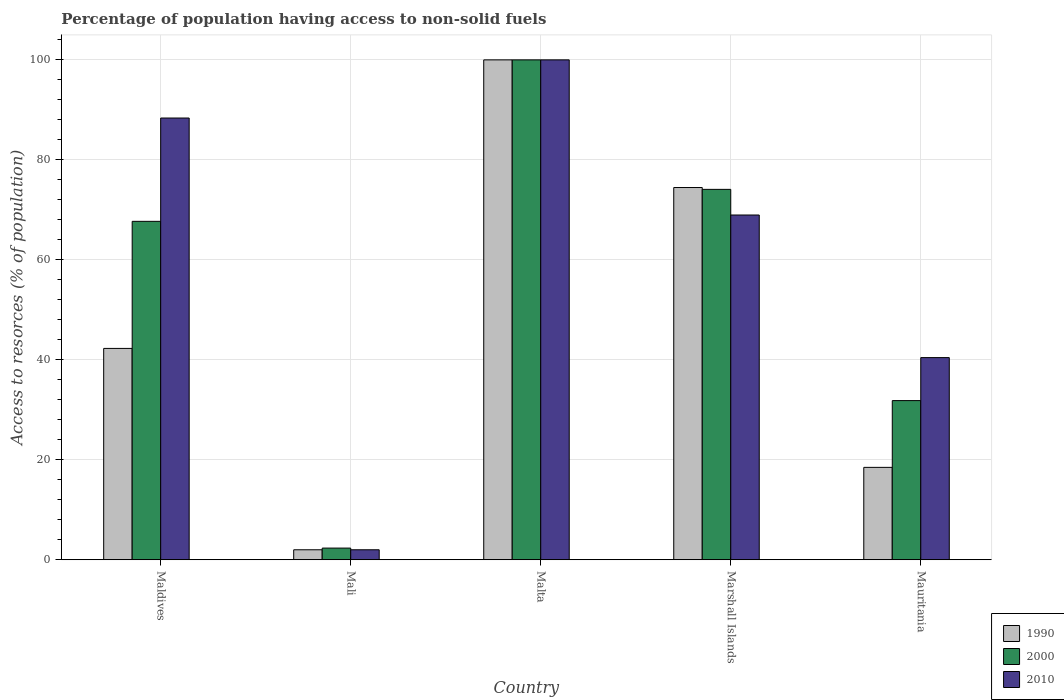How many different coloured bars are there?
Provide a short and direct response. 3. How many bars are there on the 1st tick from the right?
Your response must be concise. 3. What is the label of the 5th group of bars from the left?
Offer a very short reply. Mauritania. What is the percentage of population having access to non-solid fuels in 1990 in Marshall Islands?
Offer a terse response. 74.47. Across all countries, what is the maximum percentage of population having access to non-solid fuels in 1990?
Offer a terse response. 100. Across all countries, what is the minimum percentage of population having access to non-solid fuels in 2010?
Keep it short and to the point. 2. In which country was the percentage of population having access to non-solid fuels in 1990 maximum?
Offer a terse response. Malta. In which country was the percentage of population having access to non-solid fuels in 2010 minimum?
Your response must be concise. Mali. What is the total percentage of population having access to non-solid fuels in 2010 in the graph?
Ensure brevity in your answer.  299.78. What is the difference between the percentage of population having access to non-solid fuels in 2000 in Malta and that in Marshall Islands?
Your answer should be very brief. 25.91. What is the difference between the percentage of population having access to non-solid fuels in 1990 in Malta and the percentage of population having access to non-solid fuels in 2010 in Maldives?
Offer a terse response. 11.63. What is the average percentage of population having access to non-solid fuels in 2010 per country?
Your response must be concise. 59.96. What is the difference between the percentage of population having access to non-solid fuels of/in 2010 and percentage of population having access to non-solid fuels of/in 2000 in Mauritania?
Keep it short and to the point. 8.6. What is the ratio of the percentage of population having access to non-solid fuels in 2010 in Marshall Islands to that in Mauritania?
Keep it short and to the point. 1.71. Is the percentage of population having access to non-solid fuels in 2010 in Mali less than that in Mauritania?
Your answer should be very brief. Yes. What is the difference between the highest and the second highest percentage of population having access to non-solid fuels in 2010?
Your answer should be compact. -11.63. What is the difference between the highest and the lowest percentage of population having access to non-solid fuels in 2000?
Provide a short and direct response. 97.66. In how many countries, is the percentage of population having access to non-solid fuels in 1990 greater than the average percentage of population having access to non-solid fuels in 1990 taken over all countries?
Provide a succinct answer. 2. What does the 2nd bar from the left in Malta represents?
Provide a succinct answer. 2000. What does the 2nd bar from the right in Maldives represents?
Your response must be concise. 2000. Is it the case that in every country, the sum of the percentage of population having access to non-solid fuels in 2010 and percentage of population having access to non-solid fuels in 1990 is greater than the percentage of population having access to non-solid fuels in 2000?
Provide a succinct answer. Yes. How many bars are there?
Provide a short and direct response. 15. How many countries are there in the graph?
Offer a very short reply. 5. What is the difference between two consecutive major ticks on the Y-axis?
Keep it short and to the point. 20. Are the values on the major ticks of Y-axis written in scientific E-notation?
Offer a terse response. No. Does the graph contain grids?
Your answer should be very brief. Yes. Where does the legend appear in the graph?
Ensure brevity in your answer.  Bottom right. How are the legend labels stacked?
Your answer should be compact. Vertical. What is the title of the graph?
Give a very brief answer. Percentage of population having access to non-solid fuels. Does "1988" appear as one of the legend labels in the graph?
Your answer should be very brief. No. What is the label or title of the Y-axis?
Ensure brevity in your answer.  Access to resorces (% of population). What is the Access to resorces (% of population) in 1990 in Maldives?
Your answer should be very brief. 42.28. What is the Access to resorces (% of population) of 2000 in Maldives?
Keep it short and to the point. 67.7. What is the Access to resorces (% of population) in 2010 in Maldives?
Your answer should be very brief. 88.37. What is the Access to resorces (% of population) of 1990 in Mali?
Give a very brief answer. 2. What is the Access to resorces (% of population) in 2000 in Mali?
Keep it short and to the point. 2.34. What is the Access to resorces (% of population) of 2010 in Mali?
Keep it short and to the point. 2. What is the Access to resorces (% of population) of 1990 in Marshall Islands?
Make the answer very short. 74.47. What is the Access to resorces (% of population) of 2000 in Marshall Islands?
Offer a very short reply. 74.09. What is the Access to resorces (% of population) of 2010 in Marshall Islands?
Your answer should be compact. 68.97. What is the Access to resorces (% of population) of 1990 in Mauritania?
Your response must be concise. 18.48. What is the Access to resorces (% of population) in 2000 in Mauritania?
Your response must be concise. 31.84. What is the Access to resorces (% of population) of 2010 in Mauritania?
Your answer should be very brief. 40.44. Across all countries, what is the maximum Access to resorces (% of population) of 2010?
Your answer should be very brief. 100. Across all countries, what is the minimum Access to resorces (% of population) of 1990?
Keep it short and to the point. 2. Across all countries, what is the minimum Access to resorces (% of population) of 2000?
Keep it short and to the point. 2.34. Across all countries, what is the minimum Access to resorces (% of population) of 2010?
Your answer should be very brief. 2. What is the total Access to resorces (% of population) in 1990 in the graph?
Offer a very short reply. 237.23. What is the total Access to resorces (% of population) in 2000 in the graph?
Keep it short and to the point. 275.97. What is the total Access to resorces (% of population) in 2010 in the graph?
Provide a succinct answer. 299.78. What is the difference between the Access to resorces (% of population) in 1990 in Maldives and that in Mali?
Your response must be concise. 40.28. What is the difference between the Access to resorces (% of population) of 2000 in Maldives and that in Mali?
Make the answer very short. 65.36. What is the difference between the Access to resorces (% of population) of 2010 in Maldives and that in Mali?
Your response must be concise. 86.37. What is the difference between the Access to resorces (% of population) in 1990 in Maldives and that in Malta?
Your response must be concise. -57.72. What is the difference between the Access to resorces (% of population) of 2000 in Maldives and that in Malta?
Make the answer very short. -32.3. What is the difference between the Access to resorces (% of population) of 2010 in Maldives and that in Malta?
Provide a succinct answer. -11.63. What is the difference between the Access to resorces (% of population) in 1990 in Maldives and that in Marshall Islands?
Provide a short and direct response. -32.19. What is the difference between the Access to resorces (% of population) in 2000 in Maldives and that in Marshall Islands?
Your answer should be compact. -6.4. What is the difference between the Access to resorces (% of population) in 2010 in Maldives and that in Marshall Islands?
Make the answer very short. 19.4. What is the difference between the Access to resorces (% of population) in 1990 in Maldives and that in Mauritania?
Offer a terse response. 23.79. What is the difference between the Access to resorces (% of population) in 2000 in Maldives and that in Mauritania?
Offer a very short reply. 35.86. What is the difference between the Access to resorces (% of population) of 2010 in Maldives and that in Mauritania?
Your response must be concise. 47.93. What is the difference between the Access to resorces (% of population) in 1990 in Mali and that in Malta?
Offer a very short reply. -98. What is the difference between the Access to resorces (% of population) in 2000 in Mali and that in Malta?
Your answer should be compact. -97.66. What is the difference between the Access to resorces (% of population) in 2010 in Mali and that in Malta?
Your answer should be very brief. -98. What is the difference between the Access to resorces (% of population) of 1990 in Mali and that in Marshall Islands?
Your answer should be very brief. -72.47. What is the difference between the Access to resorces (% of population) of 2000 in Mali and that in Marshall Islands?
Your answer should be compact. -71.76. What is the difference between the Access to resorces (% of population) in 2010 in Mali and that in Marshall Islands?
Offer a very short reply. -66.97. What is the difference between the Access to resorces (% of population) of 1990 in Mali and that in Mauritania?
Ensure brevity in your answer.  -16.48. What is the difference between the Access to resorces (% of population) of 2000 in Mali and that in Mauritania?
Your answer should be compact. -29.5. What is the difference between the Access to resorces (% of population) of 2010 in Mali and that in Mauritania?
Provide a short and direct response. -38.44. What is the difference between the Access to resorces (% of population) in 1990 in Malta and that in Marshall Islands?
Ensure brevity in your answer.  25.53. What is the difference between the Access to resorces (% of population) of 2000 in Malta and that in Marshall Islands?
Offer a terse response. 25.91. What is the difference between the Access to resorces (% of population) of 2010 in Malta and that in Marshall Islands?
Give a very brief answer. 31.03. What is the difference between the Access to resorces (% of population) in 1990 in Malta and that in Mauritania?
Offer a very short reply. 81.52. What is the difference between the Access to resorces (% of population) in 2000 in Malta and that in Mauritania?
Provide a short and direct response. 68.16. What is the difference between the Access to resorces (% of population) of 2010 in Malta and that in Mauritania?
Provide a succinct answer. 59.56. What is the difference between the Access to resorces (% of population) in 1990 in Marshall Islands and that in Mauritania?
Ensure brevity in your answer.  55.98. What is the difference between the Access to resorces (% of population) of 2000 in Marshall Islands and that in Mauritania?
Your answer should be very brief. 42.25. What is the difference between the Access to resorces (% of population) of 2010 in Marshall Islands and that in Mauritania?
Provide a short and direct response. 28.53. What is the difference between the Access to resorces (% of population) of 1990 in Maldives and the Access to resorces (% of population) of 2000 in Mali?
Keep it short and to the point. 39.94. What is the difference between the Access to resorces (% of population) in 1990 in Maldives and the Access to resorces (% of population) in 2010 in Mali?
Offer a very short reply. 40.28. What is the difference between the Access to resorces (% of population) of 2000 in Maldives and the Access to resorces (% of population) of 2010 in Mali?
Make the answer very short. 65.7. What is the difference between the Access to resorces (% of population) of 1990 in Maldives and the Access to resorces (% of population) of 2000 in Malta?
Your response must be concise. -57.72. What is the difference between the Access to resorces (% of population) of 1990 in Maldives and the Access to resorces (% of population) of 2010 in Malta?
Provide a succinct answer. -57.72. What is the difference between the Access to resorces (% of population) of 2000 in Maldives and the Access to resorces (% of population) of 2010 in Malta?
Your response must be concise. -32.3. What is the difference between the Access to resorces (% of population) in 1990 in Maldives and the Access to resorces (% of population) in 2000 in Marshall Islands?
Your answer should be very brief. -31.82. What is the difference between the Access to resorces (% of population) in 1990 in Maldives and the Access to resorces (% of population) in 2010 in Marshall Islands?
Provide a succinct answer. -26.69. What is the difference between the Access to resorces (% of population) in 2000 in Maldives and the Access to resorces (% of population) in 2010 in Marshall Islands?
Provide a succinct answer. -1.27. What is the difference between the Access to resorces (% of population) in 1990 in Maldives and the Access to resorces (% of population) in 2000 in Mauritania?
Provide a short and direct response. 10.44. What is the difference between the Access to resorces (% of population) in 1990 in Maldives and the Access to resorces (% of population) in 2010 in Mauritania?
Your response must be concise. 1.84. What is the difference between the Access to resorces (% of population) in 2000 in Maldives and the Access to resorces (% of population) in 2010 in Mauritania?
Make the answer very short. 27.26. What is the difference between the Access to resorces (% of population) of 1990 in Mali and the Access to resorces (% of population) of 2000 in Malta?
Make the answer very short. -98. What is the difference between the Access to resorces (% of population) in 1990 in Mali and the Access to resorces (% of population) in 2010 in Malta?
Provide a short and direct response. -98. What is the difference between the Access to resorces (% of population) of 2000 in Mali and the Access to resorces (% of population) of 2010 in Malta?
Offer a terse response. -97.66. What is the difference between the Access to resorces (% of population) in 1990 in Mali and the Access to resorces (% of population) in 2000 in Marshall Islands?
Your answer should be compact. -72.09. What is the difference between the Access to resorces (% of population) of 1990 in Mali and the Access to resorces (% of population) of 2010 in Marshall Islands?
Give a very brief answer. -66.97. What is the difference between the Access to resorces (% of population) in 2000 in Mali and the Access to resorces (% of population) in 2010 in Marshall Islands?
Your answer should be compact. -66.63. What is the difference between the Access to resorces (% of population) in 1990 in Mali and the Access to resorces (% of population) in 2000 in Mauritania?
Your response must be concise. -29.84. What is the difference between the Access to resorces (% of population) in 1990 in Mali and the Access to resorces (% of population) in 2010 in Mauritania?
Make the answer very short. -38.44. What is the difference between the Access to resorces (% of population) in 2000 in Mali and the Access to resorces (% of population) in 2010 in Mauritania?
Your answer should be compact. -38.1. What is the difference between the Access to resorces (% of population) in 1990 in Malta and the Access to resorces (% of population) in 2000 in Marshall Islands?
Your response must be concise. 25.91. What is the difference between the Access to resorces (% of population) of 1990 in Malta and the Access to resorces (% of population) of 2010 in Marshall Islands?
Give a very brief answer. 31.03. What is the difference between the Access to resorces (% of population) of 2000 in Malta and the Access to resorces (% of population) of 2010 in Marshall Islands?
Make the answer very short. 31.03. What is the difference between the Access to resorces (% of population) of 1990 in Malta and the Access to resorces (% of population) of 2000 in Mauritania?
Your answer should be very brief. 68.16. What is the difference between the Access to resorces (% of population) of 1990 in Malta and the Access to resorces (% of population) of 2010 in Mauritania?
Your response must be concise. 59.56. What is the difference between the Access to resorces (% of population) in 2000 in Malta and the Access to resorces (% of population) in 2010 in Mauritania?
Your response must be concise. 59.56. What is the difference between the Access to resorces (% of population) in 1990 in Marshall Islands and the Access to resorces (% of population) in 2000 in Mauritania?
Provide a short and direct response. 42.62. What is the difference between the Access to resorces (% of population) of 1990 in Marshall Islands and the Access to resorces (% of population) of 2010 in Mauritania?
Keep it short and to the point. 34.02. What is the difference between the Access to resorces (% of population) of 2000 in Marshall Islands and the Access to resorces (% of population) of 2010 in Mauritania?
Ensure brevity in your answer.  33.65. What is the average Access to resorces (% of population) in 1990 per country?
Your response must be concise. 47.45. What is the average Access to resorces (% of population) in 2000 per country?
Give a very brief answer. 55.19. What is the average Access to resorces (% of population) in 2010 per country?
Your response must be concise. 59.96. What is the difference between the Access to resorces (% of population) of 1990 and Access to resorces (% of population) of 2000 in Maldives?
Give a very brief answer. -25.42. What is the difference between the Access to resorces (% of population) of 1990 and Access to resorces (% of population) of 2010 in Maldives?
Make the answer very short. -46.09. What is the difference between the Access to resorces (% of population) of 2000 and Access to resorces (% of population) of 2010 in Maldives?
Your answer should be very brief. -20.67. What is the difference between the Access to resorces (% of population) in 1990 and Access to resorces (% of population) in 2000 in Mali?
Your answer should be very brief. -0.34. What is the difference between the Access to resorces (% of population) in 2000 and Access to resorces (% of population) in 2010 in Mali?
Offer a terse response. 0.34. What is the difference between the Access to resorces (% of population) in 1990 and Access to resorces (% of population) in 2000 in Malta?
Your response must be concise. 0. What is the difference between the Access to resorces (% of population) of 1990 and Access to resorces (% of population) of 2010 in Malta?
Your answer should be compact. 0. What is the difference between the Access to resorces (% of population) in 2000 and Access to resorces (% of population) in 2010 in Malta?
Provide a short and direct response. 0. What is the difference between the Access to resorces (% of population) of 1990 and Access to resorces (% of population) of 2000 in Marshall Islands?
Offer a very short reply. 0.37. What is the difference between the Access to resorces (% of population) of 1990 and Access to resorces (% of population) of 2010 in Marshall Islands?
Offer a very short reply. 5.5. What is the difference between the Access to resorces (% of population) of 2000 and Access to resorces (% of population) of 2010 in Marshall Islands?
Ensure brevity in your answer.  5.13. What is the difference between the Access to resorces (% of population) of 1990 and Access to resorces (% of population) of 2000 in Mauritania?
Provide a short and direct response. -13.36. What is the difference between the Access to resorces (% of population) of 1990 and Access to resorces (% of population) of 2010 in Mauritania?
Provide a short and direct response. -21.96. What is the difference between the Access to resorces (% of population) in 2000 and Access to resorces (% of population) in 2010 in Mauritania?
Your response must be concise. -8.6. What is the ratio of the Access to resorces (% of population) in 1990 in Maldives to that in Mali?
Provide a succinct answer. 21.14. What is the ratio of the Access to resorces (% of population) of 2000 in Maldives to that in Mali?
Make the answer very short. 28.97. What is the ratio of the Access to resorces (% of population) of 2010 in Maldives to that in Mali?
Make the answer very short. 44.18. What is the ratio of the Access to resorces (% of population) in 1990 in Maldives to that in Malta?
Offer a terse response. 0.42. What is the ratio of the Access to resorces (% of population) in 2000 in Maldives to that in Malta?
Offer a terse response. 0.68. What is the ratio of the Access to resorces (% of population) of 2010 in Maldives to that in Malta?
Offer a very short reply. 0.88. What is the ratio of the Access to resorces (% of population) in 1990 in Maldives to that in Marshall Islands?
Offer a very short reply. 0.57. What is the ratio of the Access to resorces (% of population) in 2000 in Maldives to that in Marshall Islands?
Your answer should be compact. 0.91. What is the ratio of the Access to resorces (% of population) of 2010 in Maldives to that in Marshall Islands?
Your answer should be compact. 1.28. What is the ratio of the Access to resorces (% of population) of 1990 in Maldives to that in Mauritania?
Your response must be concise. 2.29. What is the ratio of the Access to resorces (% of population) of 2000 in Maldives to that in Mauritania?
Provide a short and direct response. 2.13. What is the ratio of the Access to resorces (% of population) of 2010 in Maldives to that in Mauritania?
Your answer should be very brief. 2.19. What is the ratio of the Access to resorces (% of population) in 2000 in Mali to that in Malta?
Give a very brief answer. 0.02. What is the ratio of the Access to resorces (% of population) of 1990 in Mali to that in Marshall Islands?
Offer a terse response. 0.03. What is the ratio of the Access to resorces (% of population) in 2000 in Mali to that in Marshall Islands?
Your answer should be very brief. 0.03. What is the ratio of the Access to resorces (% of population) in 2010 in Mali to that in Marshall Islands?
Give a very brief answer. 0.03. What is the ratio of the Access to resorces (% of population) in 1990 in Mali to that in Mauritania?
Make the answer very short. 0.11. What is the ratio of the Access to resorces (% of population) in 2000 in Mali to that in Mauritania?
Provide a succinct answer. 0.07. What is the ratio of the Access to resorces (% of population) in 2010 in Mali to that in Mauritania?
Your response must be concise. 0.05. What is the ratio of the Access to resorces (% of population) in 1990 in Malta to that in Marshall Islands?
Offer a terse response. 1.34. What is the ratio of the Access to resorces (% of population) in 2000 in Malta to that in Marshall Islands?
Provide a succinct answer. 1.35. What is the ratio of the Access to resorces (% of population) of 2010 in Malta to that in Marshall Islands?
Provide a succinct answer. 1.45. What is the ratio of the Access to resorces (% of population) of 1990 in Malta to that in Mauritania?
Provide a short and direct response. 5.41. What is the ratio of the Access to resorces (% of population) of 2000 in Malta to that in Mauritania?
Your answer should be very brief. 3.14. What is the ratio of the Access to resorces (% of population) of 2010 in Malta to that in Mauritania?
Give a very brief answer. 2.47. What is the ratio of the Access to resorces (% of population) in 1990 in Marshall Islands to that in Mauritania?
Offer a very short reply. 4.03. What is the ratio of the Access to resorces (% of population) of 2000 in Marshall Islands to that in Mauritania?
Make the answer very short. 2.33. What is the ratio of the Access to resorces (% of population) in 2010 in Marshall Islands to that in Mauritania?
Ensure brevity in your answer.  1.71. What is the difference between the highest and the second highest Access to resorces (% of population) of 1990?
Make the answer very short. 25.53. What is the difference between the highest and the second highest Access to resorces (% of population) of 2000?
Make the answer very short. 25.91. What is the difference between the highest and the second highest Access to resorces (% of population) in 2010?
Make the answer very short. 11.63. What is the difference between the highest and the lowest Access to resorces (% of population) in 1990?
Your answer should be very brief. 98. What is the difference between the highest and the lowest Access to resorces (% of population) in 2000?
Your answer should be very brief. 97.66. What is the difference between the highest and the lowest Access to resorces (% of population) in 2010?
Ensure brevity in your answer.  98. 